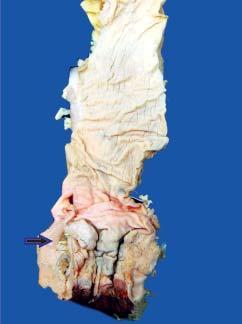s the sectioned surface of rectal wall grey-white and fleshy due to infiltration by the tumour?
Answer the question using a single word or phrase. Yes 